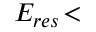Convert formula to latex. <formula><loc_0><loc_0><loc_500><loc_500>E _ { r e s } \, <</formula> 